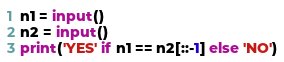<code> <loc_0><loc_0><loc_500><loc_500><_Python_>n1 = input()
n2 = input()
print('YES' if n1 == n2[::-1] else 'NO')
</code> 